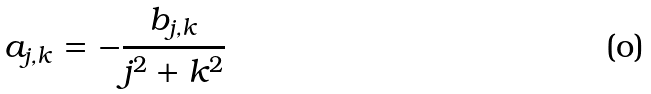Convert formula to latex. <formula><loc_0><loc_0><loc_500><loc_500>a _ { j , k } = - \frac { b _ { j , k } } { j ^ { 2 } + k ^ { 2 } }</formula> 